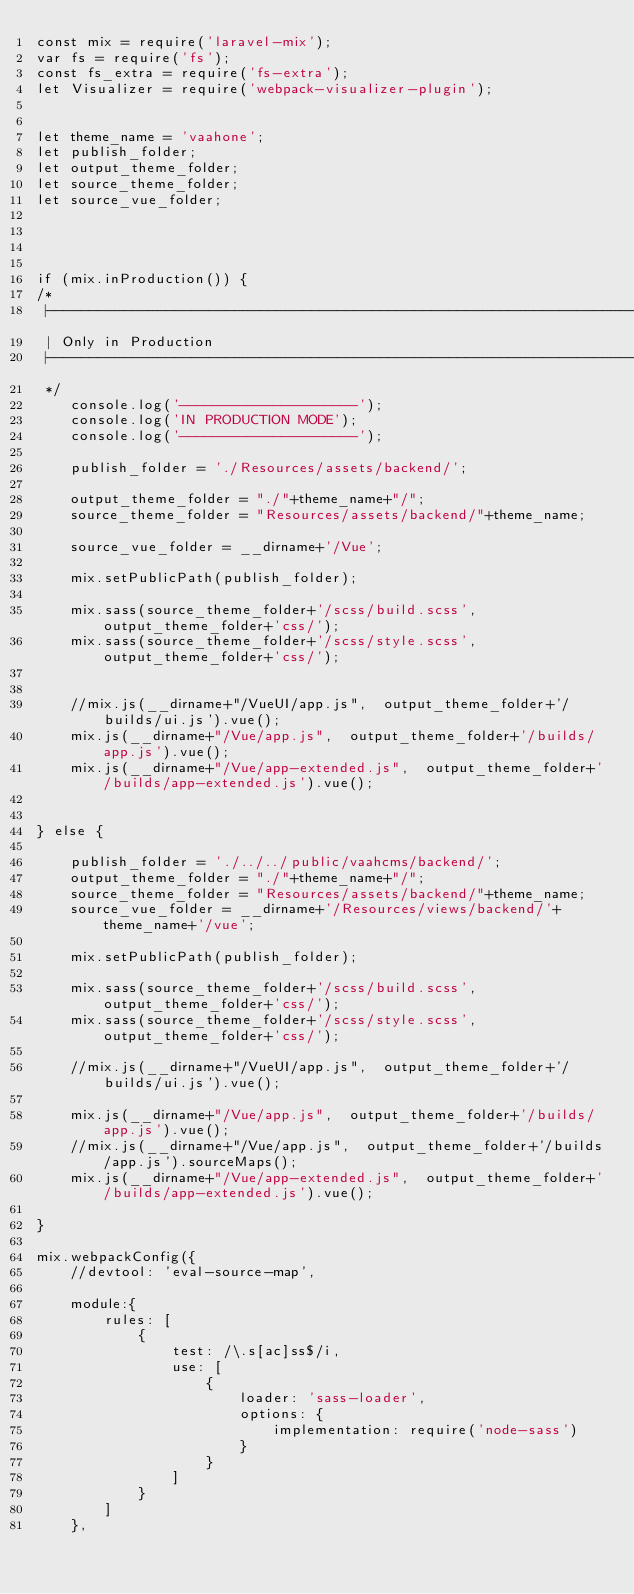<code> <loc_0><loc_0><loc_500><loc_500><_JavaScript_>const mix = require('laravel-mix');
var fs = require('fs');
const fs_extra = require('fs-extra');
let Visualizer = require('webpack-visualizer-plugin');


let theme_name = 'vaahone';
let publish_folder;
let output_theme_folder;
let source_theme_folder;
let source_vue_folder;




if (mix.inProduction()) {
/*
 |--------------------------------------------------------------------------
 | Only in Production
 |--------------------------------------------------------------------------
 */
    console.log('---------------------');
    console.log('IN PRODUCTION MODE');
    console.log('---------------------');

    publish_folder = './Resources/assets/backend/';

    output_theme_folder = "./"+theme_name+"/";
    source_theme_folder = "Resources/assets/backend/"+theme_name;

    source_vue_folder = __dirname+'/Vue';

    mix.setPublicPath(publish_folder);

    mix.sass(source_theme_folder+'/scss/build.scss', output_theme_folder+'css/');
    mix.sass(source_theme_folder+'/scss/style.scss', output_theme_folder+'css/');


    //mix.js(__dirname+"/VueUI/app.js",  output_theme_folder+'/builds/ui.js').vue();
    mix.js(__dirname+"/Vue/app.js",  output_theme_folder+'/builds/app.js').vue();
    mix.js(__dirname+"/Vue/app-extended.js",  output_theme_folder+'/builds/app-extended.js').vue();


} else {

    publish_folder = './../../public/vaahcms/backend/';
    output_theme_folder = "./"+theme_name+"/";
    source_theme_folder = "Resources/assets/backend/"+theme_name;
    source_vue_folder = __dirname+'/Resources/views/backend/'+theme_name+'/vue';

    mix.setPublicPath(publish_folder);

    mix.sass(source_theme_folder+'/scss/build.scss', output_theme_folder+'css/');
    mix.sass(source_theme_folder+'/scss/style.scss', output_theme_folder+'css/');

    //mix.js(__dirname+"/VueUI/app.js",  output_theme_folder+'/builds/ui.js').vue();

    mix.js(__dirname+"/Vue/app.js",  output_theme_folder+'/builds/app.js').vue();
    //mix.js(__dirname+"/Vue/app.js",  output_theme_folder+'/builds/app.js').sourceMaps();
    mix.js(__dirname+"/Vue/app-extended.js",  output_theme_folder+'/builds/app-extended.js').vue();

}

mix.webpackConfig({
    //devtool: 'eval-source-map',

    module:{
        rules: [
            {
                test: /\.s[ac]ss$/i,
                use: [
                    {
                        loader: 'sass-loader',
                        options: {
                            implementation: require('node-sass')
                        }
                    }
                ]
            }
        ]
    },</code> 